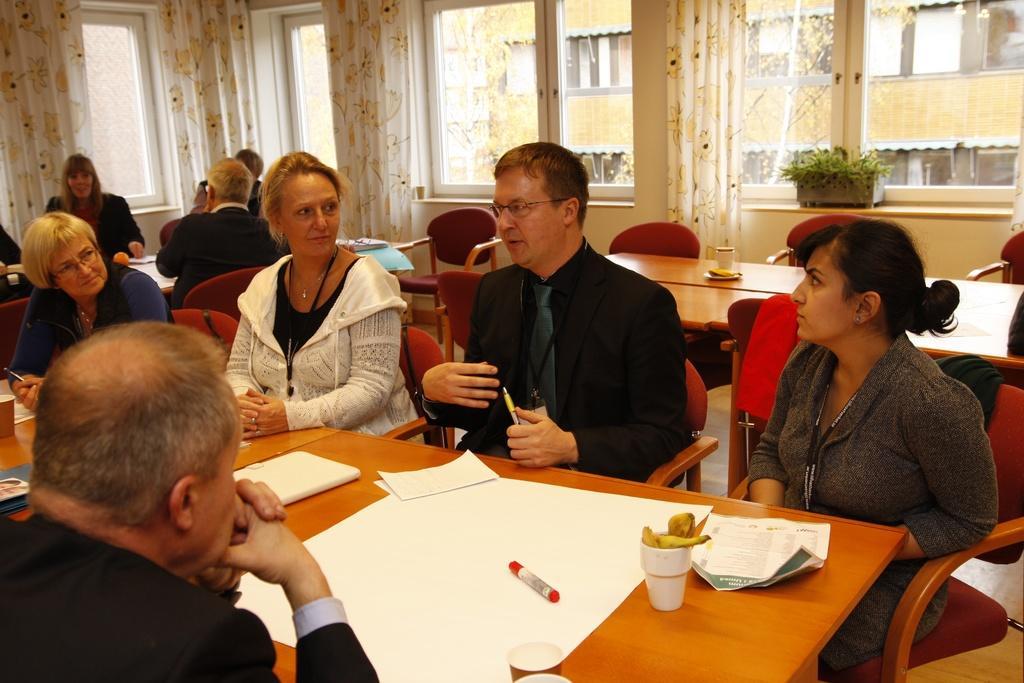Describe this image in one or two sentences. This is an inside view. Here I can see few people are sitting on the chairs around the table. On the table I can see few papers, glass and marker pen. In the background there are windows, through that windows we can see the outside view and also I can see white color curtains. 